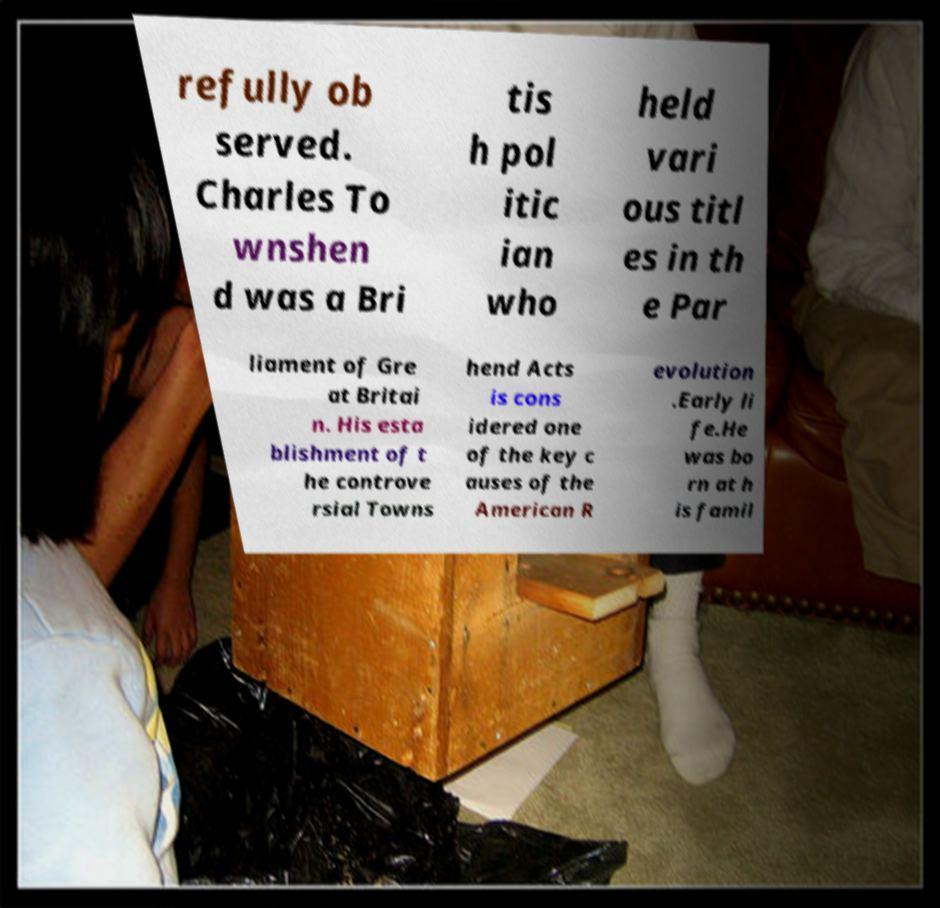Please identify and transcribe the text found in this image. refully ob served. Charles To wnshen d was a Bri tis h pol itic ian who held vari ous titl es in th e Par liament of Gre at Britai n. His esta blishment of t he controve rsial Towns hend Acts is cons idered one of the key c auses of the American R evolution .Early li fe.He was bo rn at h is famil 